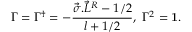Convert formula to latex. <formula><loc_0><loc_0><loc_500><loc_500>\Gamma = \Gamma ^ { \dagger } = - \frac { \vec { \sigma } . { \vec { L } } ^ { R } - 1 / 2 } { l + 1 / 2 } , \Gamma ^ { 2 } = { 1 } .</formula> 